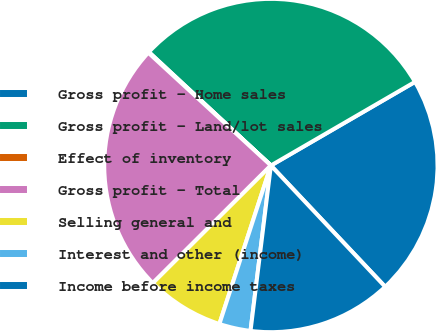Convert chart to OTSL. <chart><loc_0><loc_0><loc_500><loc_500><pie_chart><fcel>Gross profit - Home sales<fcel>Gross profit - Land/lot sales<fcel>Effect of inventory<fcel>Gross profit - Total<fcel>Selling general and<fcel>Interest and other (income)<fcel>Income before income taxes<nl><fcel>21.34%<fcel>29.71%<fcel>0.08%<fcel>24.31%<fcel>7.53%<fcel>3.05%<fcel>13.98%<nl></chart> 